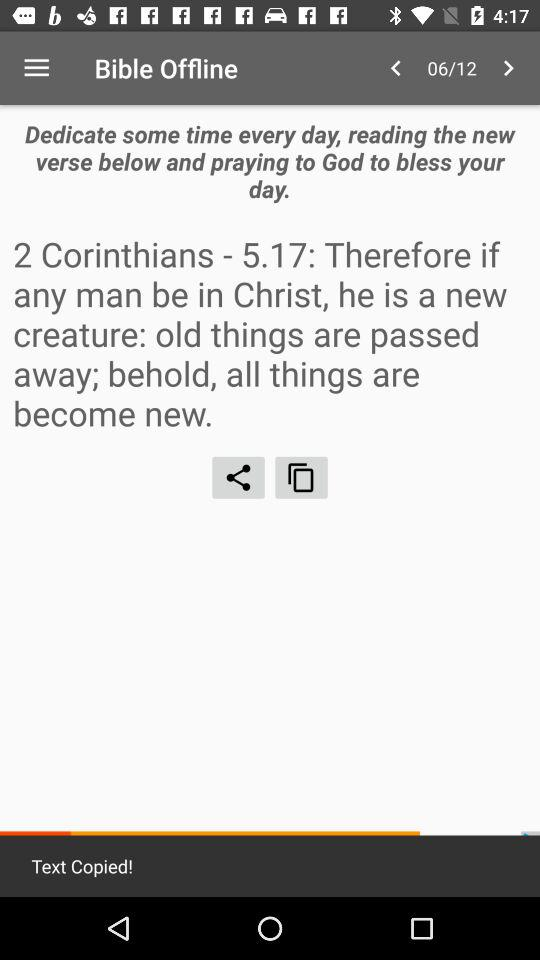At which page am I? You are at the sixth page. 